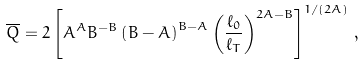Convert formula to latex. <formula><loc_0><loc_0><loc_500><loc_500>\overline { Q } = 2 \left [ A ^ { A } B ^ { - B } \left ( B - A \right ) ^ { B - A } \left ( \frac { \ell _ { 0 } } { \ell _ { T } } \right ) ^ { 2 A - B } \right ] ^ { 1 / ( 2 A ) } \, ,</formula> 